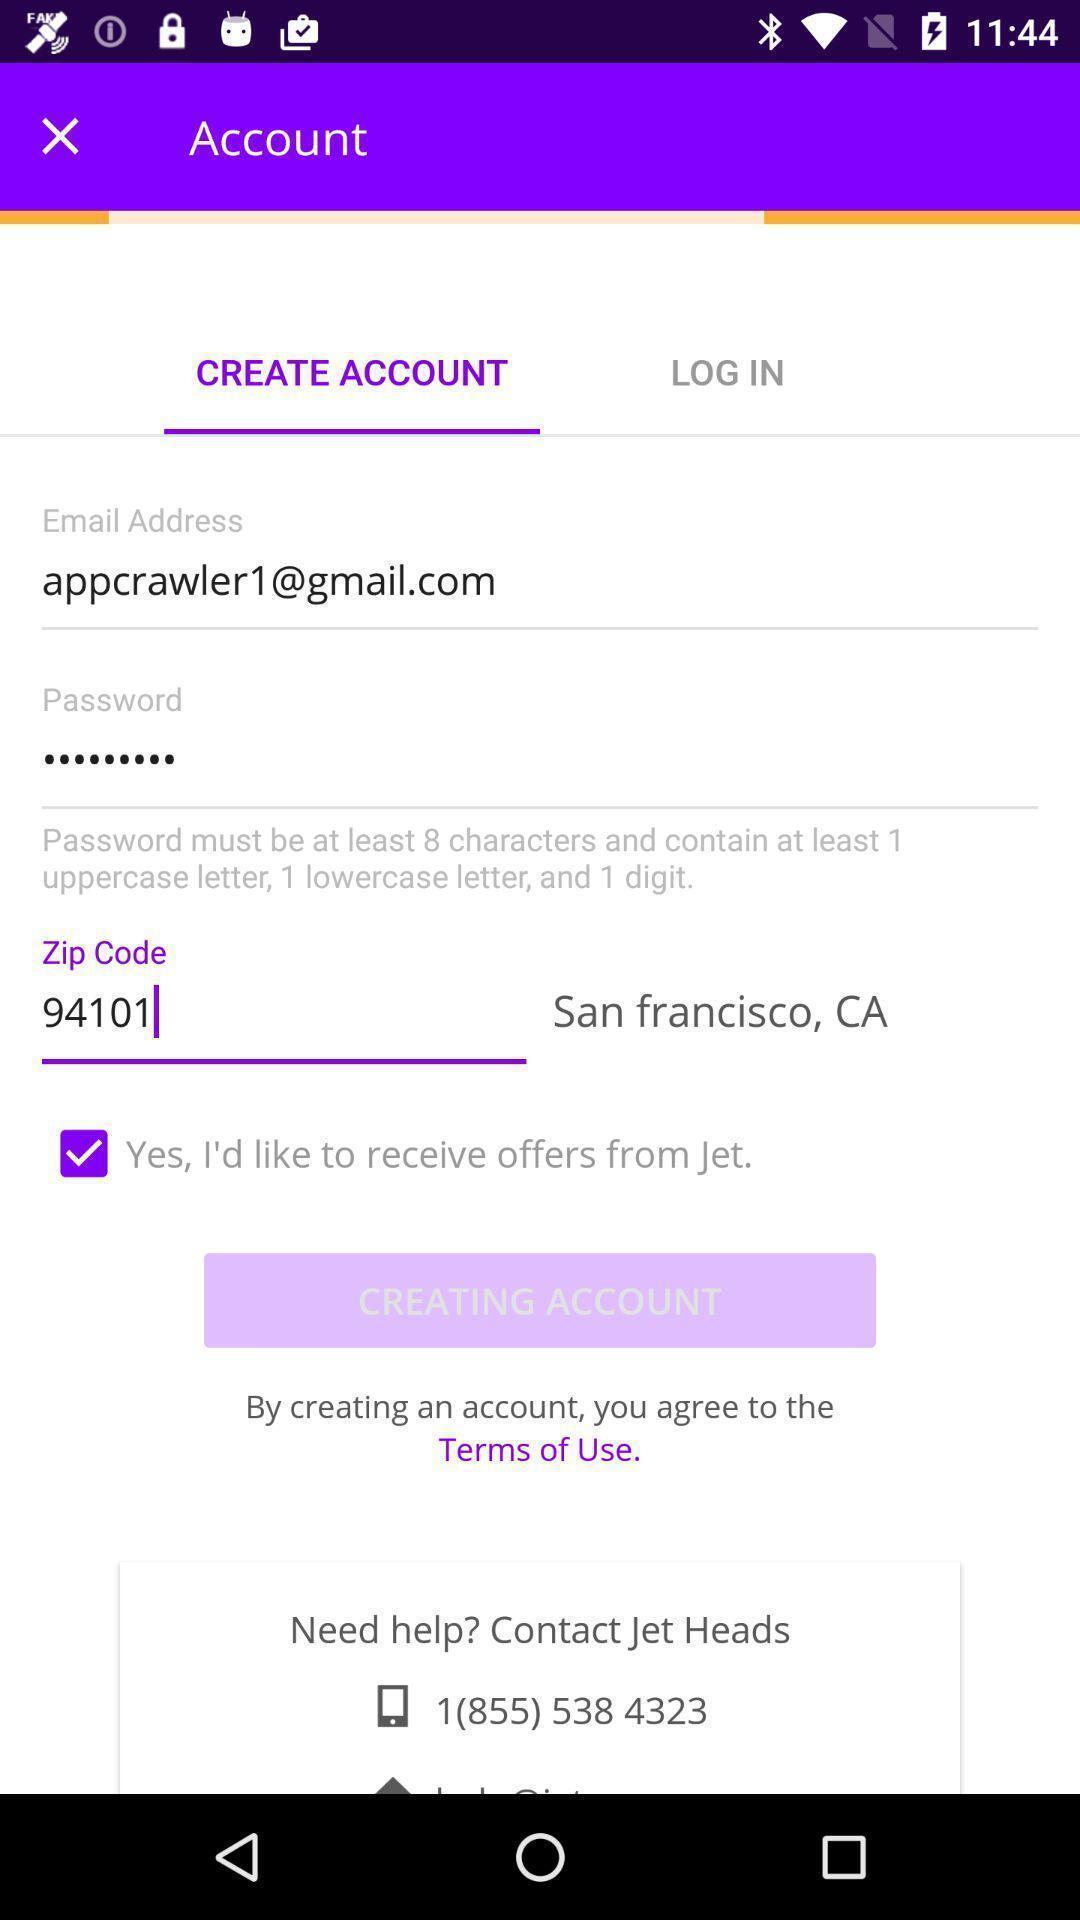What details can you identify in this image? Page to create an account on app. 